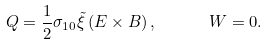Convert formula to latex. <formula><loc_0><loc_0><loc_500><loc_500>Q = \frac { 1 } { 2 } \sigma _ { 1 0 } \tilde { \xi } \left ( E \times B \right ) , \quad \ \ W = 0 .</formula> 